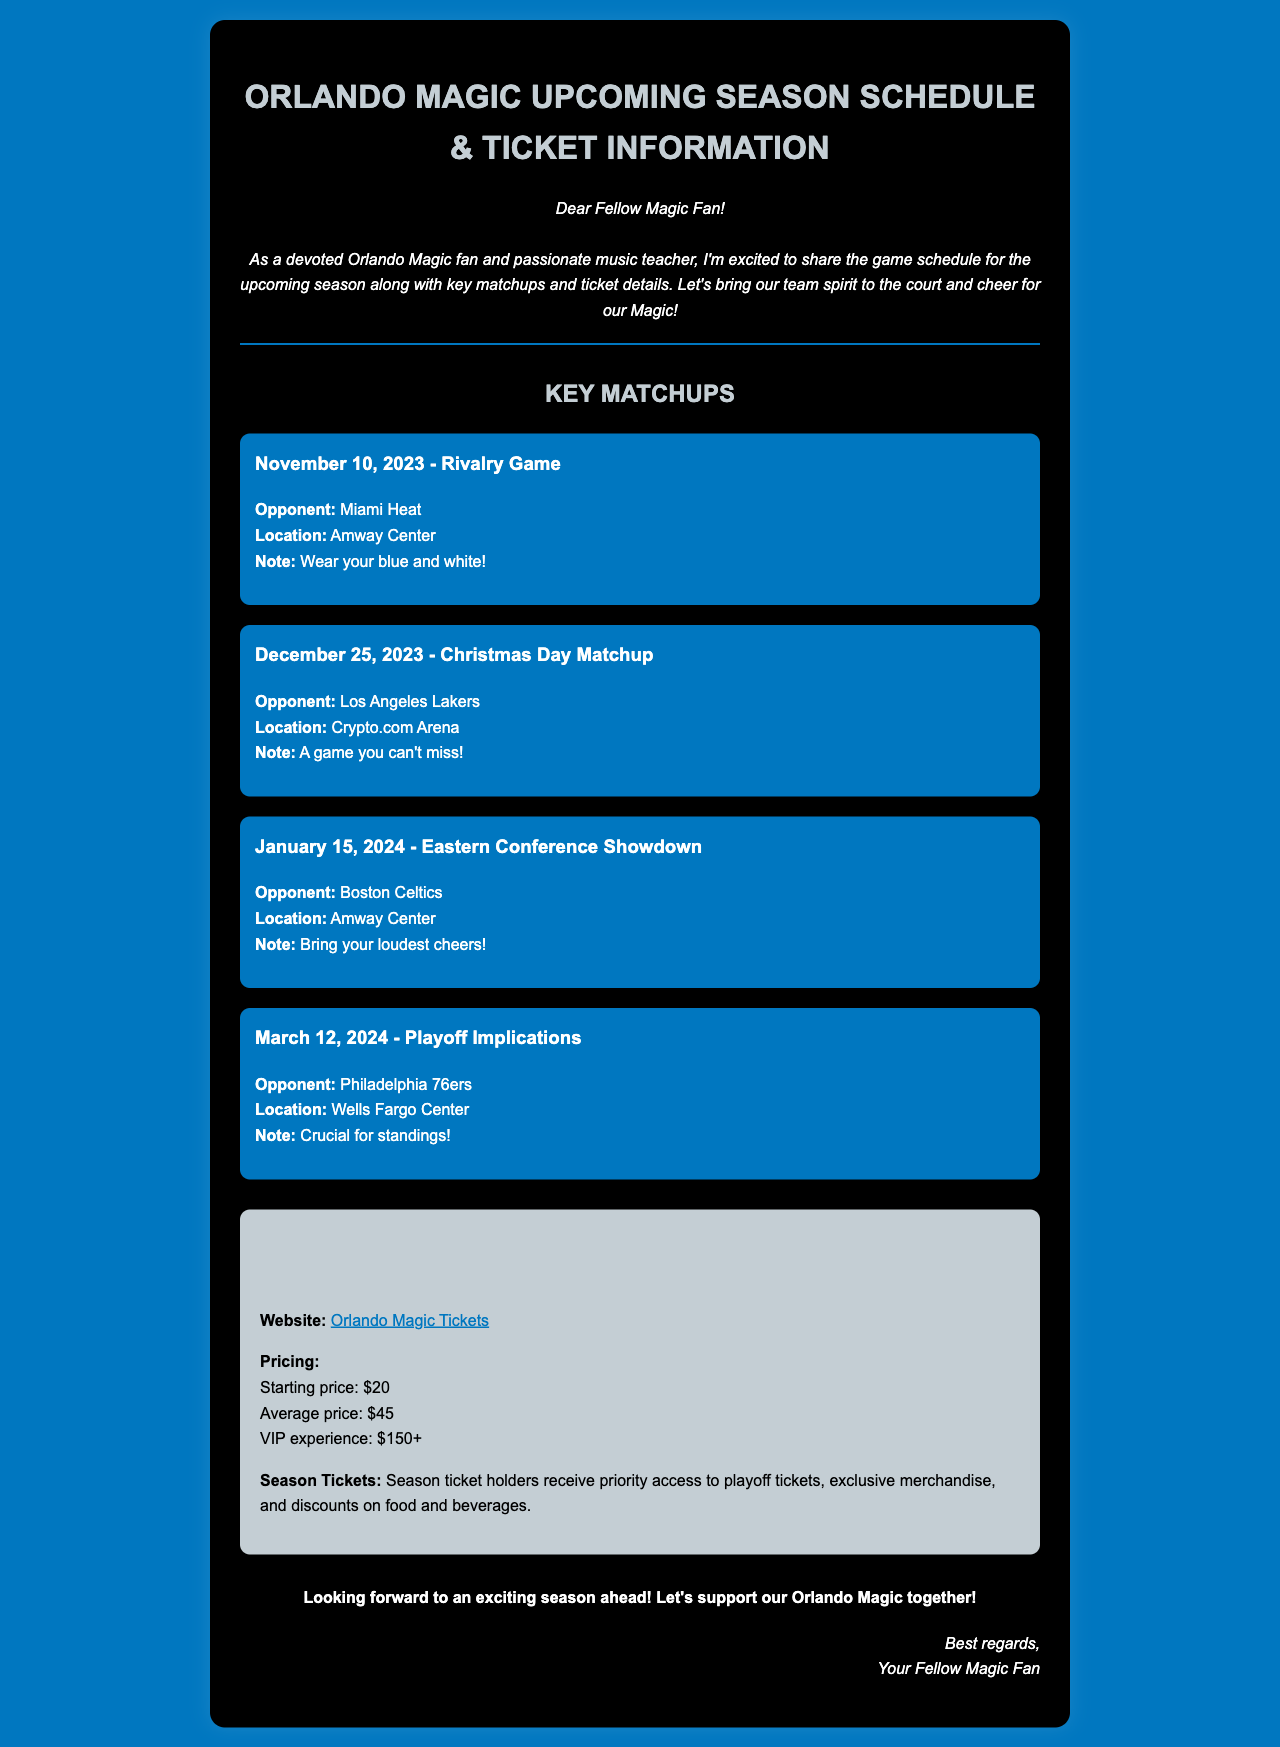What is the first key matchup date? The first key matchup is listed as November 10, 2023.
Answer: November 10, 2023 Who is the opponent on Christmas Day? The opponent for the Christmas Day matchup is the Los Angeles Lakers.
Answer: Los Angeles Lakers Where is the Eastern Conference Showdown taking place? The Eastern Conference Showdown will be held at Amway Center.
Answer: Amway Center What is the starting ticket price? The document states that the starting ticket price is $20.
Answer: $20 What is the VIP experience ticket price? The VIP experience starting price is mentioned as $150+.
Answer: $150+ How many key matchups are listed in total? There are four key matchups mentioned in the document.
Answer: Four What can season ticket holders receive? Season ticket holders can receive priority access to playoff tickets.
Answer: Priority access to playoff tickets What color should fans wear for the rivalry game? Fans are encouraged to wear blue and white for the rivalry game.
Answer: Blue and white On what date is the matchup with the Philadelphia 76ers? The matchup with the Philadelphia 76ers takes place on March 12, 2024.
Answer: March 12, 2024 